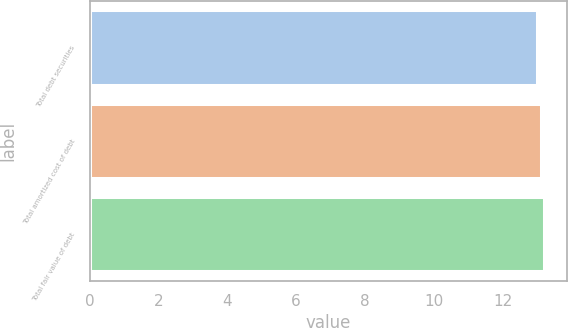Convert chart to OTSL. <chart><loc_0><loc_0><loc_500><loc_500><bar_chart><fcel>Total debt securities<fcel>Total amortized cost of debt<fcel>Total fair value of debt<nl><fcel>13<fcel>13.1<fcel>13.2<nl></chart> 